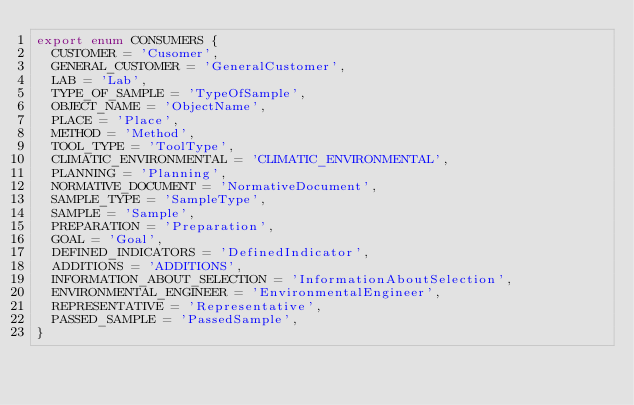<code> <loc_0><loc_0><loc_500><loc_500><_TypeScript_>export enum CONSUMERS {
  CUSTOMER = 'Cusomer',
  GENERAL_CUSTOMER = 'GeneralCustomer',
  LAB = 'Lab',
  TYPE_OF_SAMPLE = 'TypeOfSample',
  OBJECT_NAME = 'ObjectName',
  PLACE = 'Place',
  METHOD = 'Method',
  TOOL_TYPE = 'ToolType',
  CLIMATIC_ENVIRONMENTAL = 'CLIMATIC_ENVIRONMENTAL',
  PLANNING = 'Planning',
  NORMATIVE_DOCUMENT = 'NormativeDocument',
  SAMPLE_TYPE = 'SampleType',
  SAMPLE = 'Sample',
  PREPARATION = 'Preparation',
  GOAL = 'Goal',
  DEFINED_INDICATORS = 'DefinedIndicator',
  ADDITIONS = 'ADDITIONS',
  INFORMATION_ABOUT_SELECTION = 'InformationAboutSelection',
  ENVIRONMENTAL_ENGINEER = 'EnvironmentalEngineer',
  REPRESENTATIVE = 'Representative',
  PASSED_SAMPLE = 'PassedSample',
}
</code> 